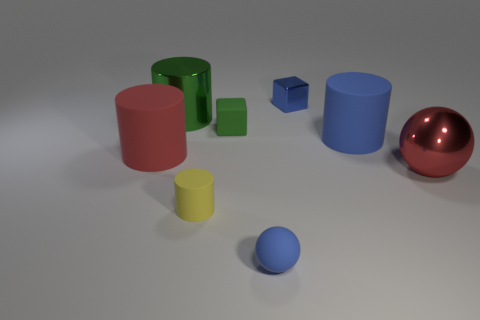Subtract all brown cylinders. Subtract all green blocks. How many cylinders are left? 4 Add 2 blue shiny blocks. How many objects exist? 10 Subtract all spheres. How many objects are left? 6 Add 3 tiny green matte things. How many tiny green matte things are left? 4 Add 4 large green metallic things. How many large green metallic things exist? 5 Subtract 0 purple cylinders. How many objects are left? 8 Subtract all tiny blue metal objects. Subtract all tiny matte cylinders. How many objects are left? 6 